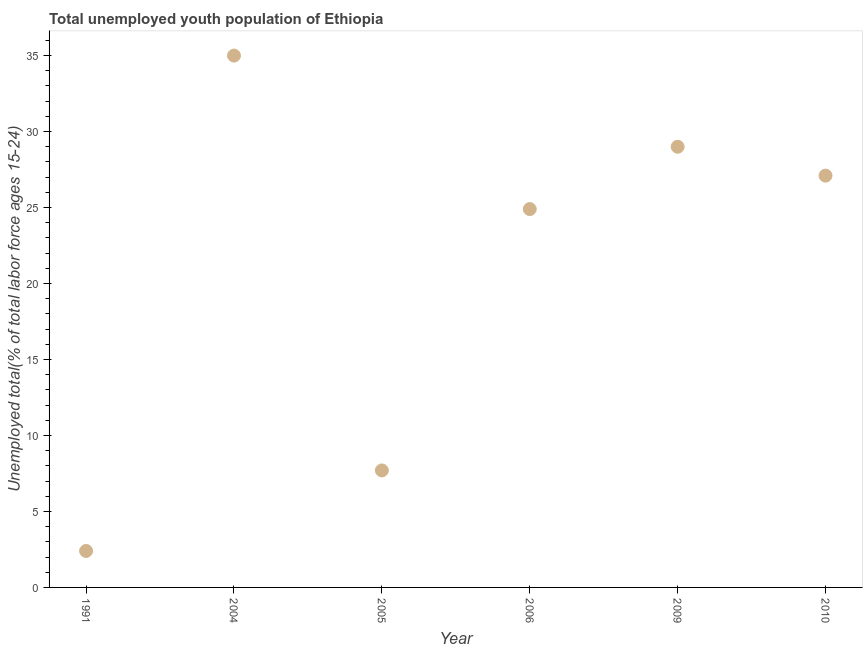What is the unemployed youth in 2005?
Your answer should be compact. 7.7. Across all years, what is the maximum unemployed youth?
Ensure brevity in your answer.  35. Across all years, what is the minimum unemployed youth?
Offer a very short reply. 2.4. In which year was the unemployed youth minimum?
Offer a very short reply. 1991. What is the sum of the unemployed youth?
Your response must be concise. 126.1. What is the difference between the unemployed youth in 2005 and 2010?
Offer a terse response. -19.4. What is the average unemployed youth per year?
Offer a terse response. 21.02. In how many years, is the unemployed youth greater than 22 %?
Provide a short and direct response. 4. What is the ratio of the unemployed youth in 2004 to that in 2005?
Offer a terse response. 4.55. What is the difference between the highest and the second highest unemployed youth?
Keep it short and to the point. 6. What is the difference between the highest and the lowest unemployed youth?
Offer a very short reply. 32.6. In how many years, is the unemployed youth greater than the average unemployed youth taken over all years?
Offer a very short reply. 4. Does the unemployed youth monotonically increase over the years?
Offer a very short reply. No. How many dotlines are there?
Your response must be concise. 1. How many years are there in the graph?
Your response must be concise. 6. Does the graph contain any zero values?
Your answer should be very brief. No. Does the graph contain grids?
Your answer should be very brief. No. What is the title of the graph?
Offer a very short reply. Total unemployed youth population of Ethiopia. What is the label or title of the X-axis?
Keep it short and to the point. Year. What is the label or title of the Y-axis?
Your answer should be very brief. Unemployed total(% of total labor force ages 15-24). What is the Unemployed total(% of total labor force ages 15-24) in 1991?
Provide a short and direct response. 2.4. What is the Unemployed total(% of total labor force ages 15-24) in 2004?
Provide a short and direct response. 35. What is the Unemployed total(% of total labor force ages 15-24) in 2005?
Offer a terse response. 7.7. What is the Unemployed total(% of total labor force ages 15-24) in 2006?
Give a very brief answer. 24.9. What is the Unemployed total(% of total labor force ages 15-24) in 2010?
Make the answer very short. 27.1. What is the difference between the Unemployed total(% of total labor force ages 15-24) in 1991 and 2004?
Your response must be concise. -32.6. What is the difference between the Unemployed total(% of total labor force ages 15-24) in 1991 and 2006?
Provide a short and direct response. -22.5. What is the difference between the Unemployed total(% of total labor force ages 15-24) in 1991 and 2009?
Make the answer very short. -26.6. What is the difference between the Unemployed total(% of total labor force ages 15-24) in 1991 and 2010?
Ensure brevity in your answer.  -24.7. What is the difference between the Unemployed total(% of total labor force ages 15-24) in 2004 and 2005?
Offer a very short reply. 27.3. What is the difference between the Unemployed total(% of total labor force ages 15-24) in 2004 and 2009?
Make the answer very short. 6. What is the difference between the Unemployed total(% of total labor force ages 15-24) in 2004 and 2010?
Your answer should be compact. 7.9. What is the difference between the Unemployed total(% of total labor force ages 15-24) in 2005 and 2006?
Your response must be concise. -17.2. What is the difference between the Unemployed total(% of total labor force ages 15-24) in 2005 and 2009?
Your response must be concise. -21.3. What is the difference between the Unemployed total(% of total labor force ages 15-24) in 2005 and 2010?
Your answer should be compact. -19.4. What is the ratio of the Unemployed total(% of total labor force ages 15-24) in 1991 to that in 2004?
Provide a succinct answer. 0.07. What is the ratio of the Unemployed total(% of total labor force ages 15-24) in 1991 to that in 2005?
Offer a very short reply. 0.31. What is the ratio of the Unemployed total(% of total labor force ages 15-24) in 1991 to that in 2006?
Your answer should be very brief. 0.1. What is the ratio of the Unemployed total(% of total labor force ages 15-24) in 1991 to that in 2009?
Provide a succinct answer. 0.08. What is the ratio of the Unemployed total(% of total labor force ages 15-24) in 1991 to that in 2010?
Offer a terse response. 0.09. What is the ratio of the Unemployed total(% of total labor force ages 15-24) in 2004 to that in 2005?
Provide a short and direct response. 4.54. What is the ratio of the Unemployed total(% of total labor force ages 15-24) in 2004 to that in 2006?
Give a very brief answer. 1.41. What is the ratio of the Unemployed total(% of total labor force ages 15-24) in 2004 to that in 2009?
Your answer should be very brief. 1.21. What is the ratio of the Unemployed total(% of total labor force ages 15-24) in 2004 to that in 2010?
Offer a terse response. 1.29. What is the ratio of the Unemployed total(% of total labor force ages 15-24) in 2005 to that in 2006?
Your answer should be very brief. 0.31. What is the ratio of the Unemployed total(% of total labor force ages 15-24) in 2005 to that in 2009?
Offer a terse response. 0.27. What is the ratio of the Unemployed total(% of total labor force ages 15-24) in 2005 to that in 2010?
Give a very brief answer. 0.28. What is the ratio of the Unemployed total(% of total labor force ages 15-24) in 2006 to that in 2009?
Your response must be concise. 0.86. What is the ratio of the Unemployed total(% of total labor force ages 15-24) in 2006 to that in 2010?
Offer a terse response. 0.92. What is the ratio of the Unemployed total(% of total labor force ages 15-24) in 2009 to that in 2010?
Offer a terse response. 1.07. 